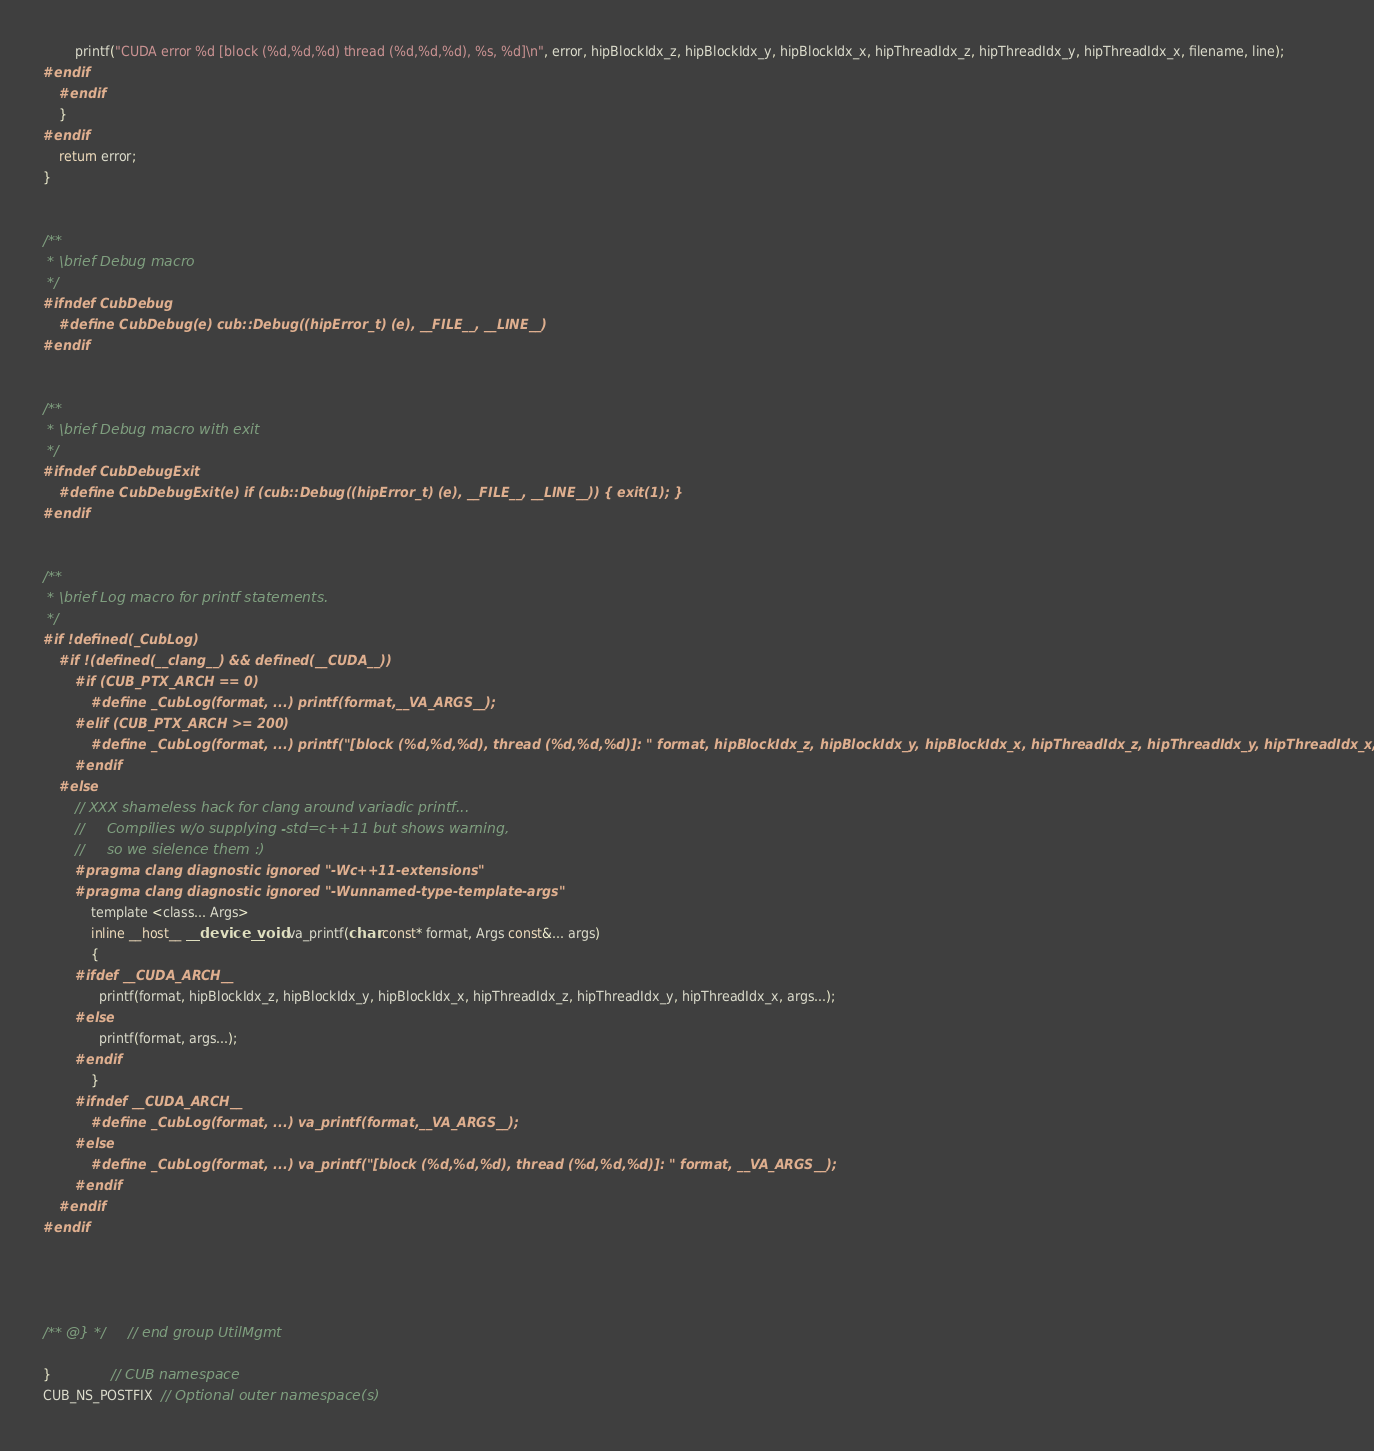<code> <loc_0><loc_0><loc_500><loc_500><_Cuda_>        printf("CUDA error %d [block (%d,%d,%d) thread (%d,%d,%d), %s, %d]\n", error, hipBlockIdx_z, hipBlockIdx_y, hipBlockIdx_x, hipThreadIdx_z, hipThreadIdx_y, hipThreadIdx_x, filename, line);
#endif
    #endif
    }
#endif
    return error;
}


/**
 * \brief Debug macro
 */
#ifndef CubDebug
    #define CubDebug(e) cub::Debug((hipError_t) (e), __FILE__, __LINE__)
#endif


/**
 * \brief Debug macro with exit
 */
#ifndef CubDebugExit
    #define CubDebugExit(e) if (cub::Debug((hipError_t) (e), __FILE__, __LINE__)) { exit(1); }
#endif


/**
 * \brief Log macro for printf statements.
 */
#if !defined(_CubLog)
    #if !(defined(__clang__) && defined(__CUDA__))
        #if (CUB_PTX_ARCH == 0)
            #define _CubLog(format, ...) printf(format,__VA_ARGS__);
        #elif (CUB_PTX_ARCH >= 200)
            #define _CubLog(format, ...) printf("[block (%d,%d,%d), thread (%d,%d,%d)]: " format, hipBlockIdx_z, hipBlockIdx_y, hipBlockIdx_x, hipThreadIdx_z, hipThreadIdx_y, hipThreadIdx_x, __VA_ARGS__);
        #endif
    #else
        // XXX shameless hack for clang around variadic printf...
        //     Compilies w/o supplying -std=c++11 but shows warning,
        //     so we sielence them :)
        #pragma clang diagnostic ignored "-Wc++11-extensions"
        #pragma clang diagnostic ignored "-Wunnamed-type-template-args"
            template <class... Args>
            inline __host__ __device__ void va_printf(char const* format, Args const&... args)
            {
        #ifdef __CUDA_ARCH__
              printf(format, hipBlockIdx_z, hipBlockIdx_y, hipBlockIdx_x, hipThreadIdx_z, hipThreadIdx_y, hipThreadIdx_x, args...);
        #else
              printf(format, args...);
        #endif
            }
        #ifndef __CUDA_ARCH__
            #define _CubLog(format, ...) va_printf(format,__VA_ARGS__);
        #else
            #define _CubLog(format, ...) va_printf("[block (%d,%d,%d), thread (%d,%d,%d)]: " format, __VA_ARGS__);
        #endif
    #endif
#endif




/** @} */       // end group UtilMgmt

}               // CUB namespace
CUB_NS_POSTFIX  // Optional outer namespace(s)
</code> 